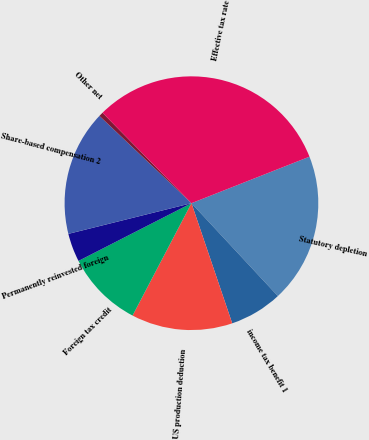<chart> <loc_0><loc_0><loc_500><loc_500><pie_chart><fcel>Statutory depletion<fcel>income tax benefit 1<fcel>US production deduction<fcel>Foreign tax credit<fcel>Permanently reinvested foreign<fcel>Share-based compensation 2<fcel>Other net<fcel>Effective tax rate<nl><fcel>19.05%<fcel>6.72%<fcel>12.89%<fcel>9.8%<fcel>3.63%<fcel>15.97%<fcel>0.55%<fcel>31.39%<nl></chart> 